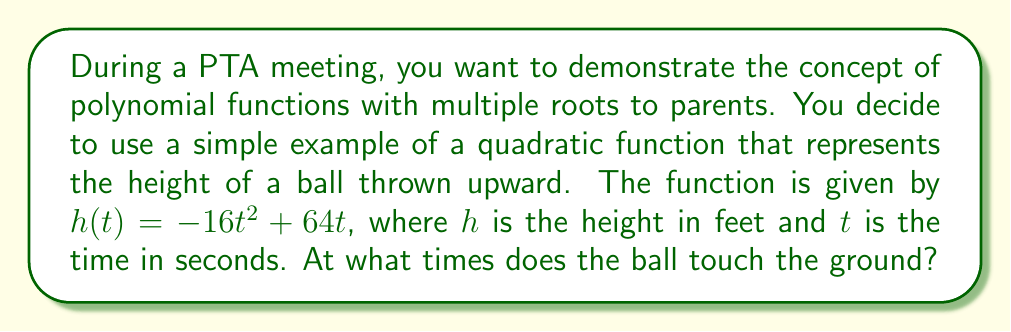Can you answer this question? Let's approach this step-by-step:

1) The ball touches the ground when its height is zero. So, we need to solve the equation:

   $h(t) = 0$

2) Substituting the given function:

   $-16t^2 + 64t = 0$

3) Factor out the common factor:

   $16t(-t + 4) = 0$

4) Using the zero product property, either $16t = 0$ or $-t + 4 = 0$

5) Solving these equations:
   
   From $16t = 0$, we get $t = 0$
   From $-t + 4 = 0$, we get $t = 4$

6) Interpret the results:
   - $t = 0$ represents the time when the ball is initially thrown (it starts at ground level)
   - $t = 4$ represents the time when the ball returns to the ground

This quadratic function has two roots, demonstrating a polynomial with multiple roots.
Answer: $t = 0$ and $t = 4$ seconds 